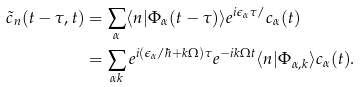<formula> <loc_0><loc_0><loc_500><loc_500>\tilde { c } _ { n } ( t - \tau , t ) & = \sum _ { \alpha } \langle n | \Phi _ { \alpha } ( t - \tau ) \rangle e ^ { i \epsilon _ { \alpha } \tau / } c _ { \alpha } ( t ) \\ & = \sum _ { \alpha k } e ^ { i ( \epsilon _ { \alpha } / \hbar { + } k \Omega ) \tau } e ^ { - i k \Omega t } \langle n | \Phi _ { \alpha , k } \rangle c _ { \alpha } ( t ) .</formula> 